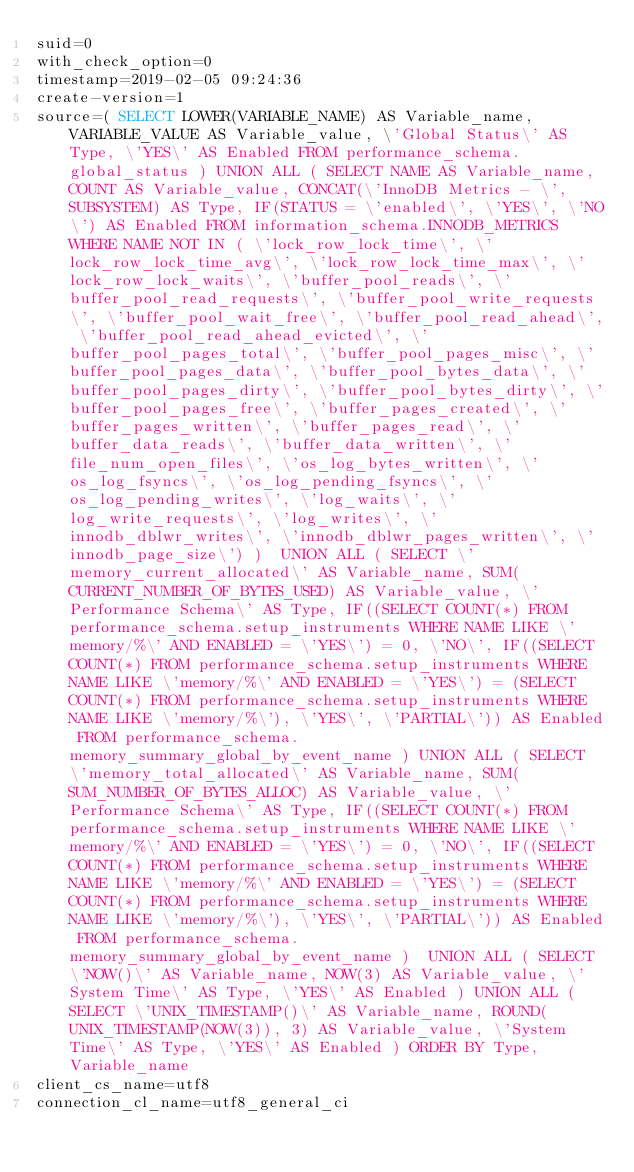<code> <loc_0><loc_0><loc_500><loc_500><_VisualBasic_>suid=0
with_check_option=0
timestamp=2019-02-05 09:24:36
create-version=1
source=( SELECT LOWER(VARIABLE_NAME) AS Variable_name, VARIABLE_VALUE AS Variable_value, \'Global Status\' AS Type, \'YES\' AS Enabled FROM performance_schema.global_status ) UNION ALL ( SELECT NAME AS Variable_name, COUNT AS Variable_value, CONCAT(\'InnoDB Metrics - \', SUBSYSTEM) AS Type, IF(STATUS = \'enabled\', \'YES\', \'NO\') AS Enabled FROM information_schema.INNODB_METRICS WHERE NAME NOT IN ( \'lock_row_lock_time\', \'lock_row_lock_time_avg\', \'lock_row_lock_time_max\', \'lock_row_lock_waits\', \'buffer_pool_reads\', \'buffer_pool_read_requests\', \'buffer_pool_write_requests\', \'buffer_pool_wait_free\', \'buffer_pool_read_ahead\', \'buffer_pool_read_ahead_evicted\', \'buffer_pool_pages_total\', \'buffer_pool_pages_misc\', \'buffer_pool_pages_data\', \'buffer_pool_bytes_data\', \'buffer_pool_pages_dirty\', \'buffer_pool_bytes_dirty\', \'buffer_pool_pages_free\', \'buffer_pages_created\', \'buffer_pages_written\', \'buffer_pages_read\', \'buffer_data_reads\', \'buffer_data_written\', \'file_num_open_files\', \'os_log_bytes_written\', \'os_log_fsyncs\', \'os_log_pending_fsyncs\', \'os_log_pending_writes\', \'log_waits\', \'log_write_requests\', \'log_writes\', \'innodb_dblwr_writes\', \'innodb_dblwr_pages_written\', \'innodb_page_size\') )  UNION ALL ( SELECT \'memory_current_allocated\' AS Variable_name, SUM(CURRENT_NUMBER_OF_BYTES_USED) AS Variable_value, \'Performance Schema\' AS Type, IF((SELECT COUNT(*) FROM performance_schema.setup_instruments WHERE NAME LIKE \'memory/%\' AND ENABLED = \'YES\') = 0, \'NO\', IF((SELECT COUNT(*) FROM performance_schema.setup_instruments WHERE NAME LIKE \'memory/%\' AND ENABLED = \'YES\') = (SELECT COUNT(*) FROM performance_schema.setup_instruments WHERE NAME LIKE \'memory/%\'), \'YES\', \'PARTIAL\')) AS Enabled FROM performance_schema.memory_summary_global_by_event_name ) UNION ALL ( SELECT \'memory_total_allocated\' AS Variable_name, SUM(SUM_NUMBER_OF_BYTES_ALLOC) AS Variable_value, \'Performance Schema\' AS Type, IF((SELECT COUNT(*) FROM performance_schema.setup_instruments WHERE NAME LIKE \'memory/%\' AND ENABLED = \'YES\') = 0, \'NO\', IF((SELECT COUNT(*) FROM performance_schema.setup_instruments WHERE NAME LIKE \'memory/%\' AND ENABLED = \'YES\') = (SELECT COUNT(*) FROM performance_schema.setup_instruments WHERE NAME LIKE \'memory/%\'), \'YES\', \'PARTIAL\')) AS Enabled FROM performance_schema.memory_summary_global_by_event_name )  UNION ALL ( SELECT \'NOW()\' AS Variable_name, NOW(3) AS Variable_value, \'System Time\' AS Type, \'YES\' AS Enabled ) UNION ALL ( SELECT \'UNIX_TIMESTAMP()\' AS Variable_name, ROUND(UNIX_TIMESTAMP(NOW(3)), 3) AS Variable_value, \'System Time\' AS Type, \'YES\' AS Enabled ) ORDER BY Type, Variable_name
client_cs_name=utf8
connection_cl_name=utf8_general_ci</code> 